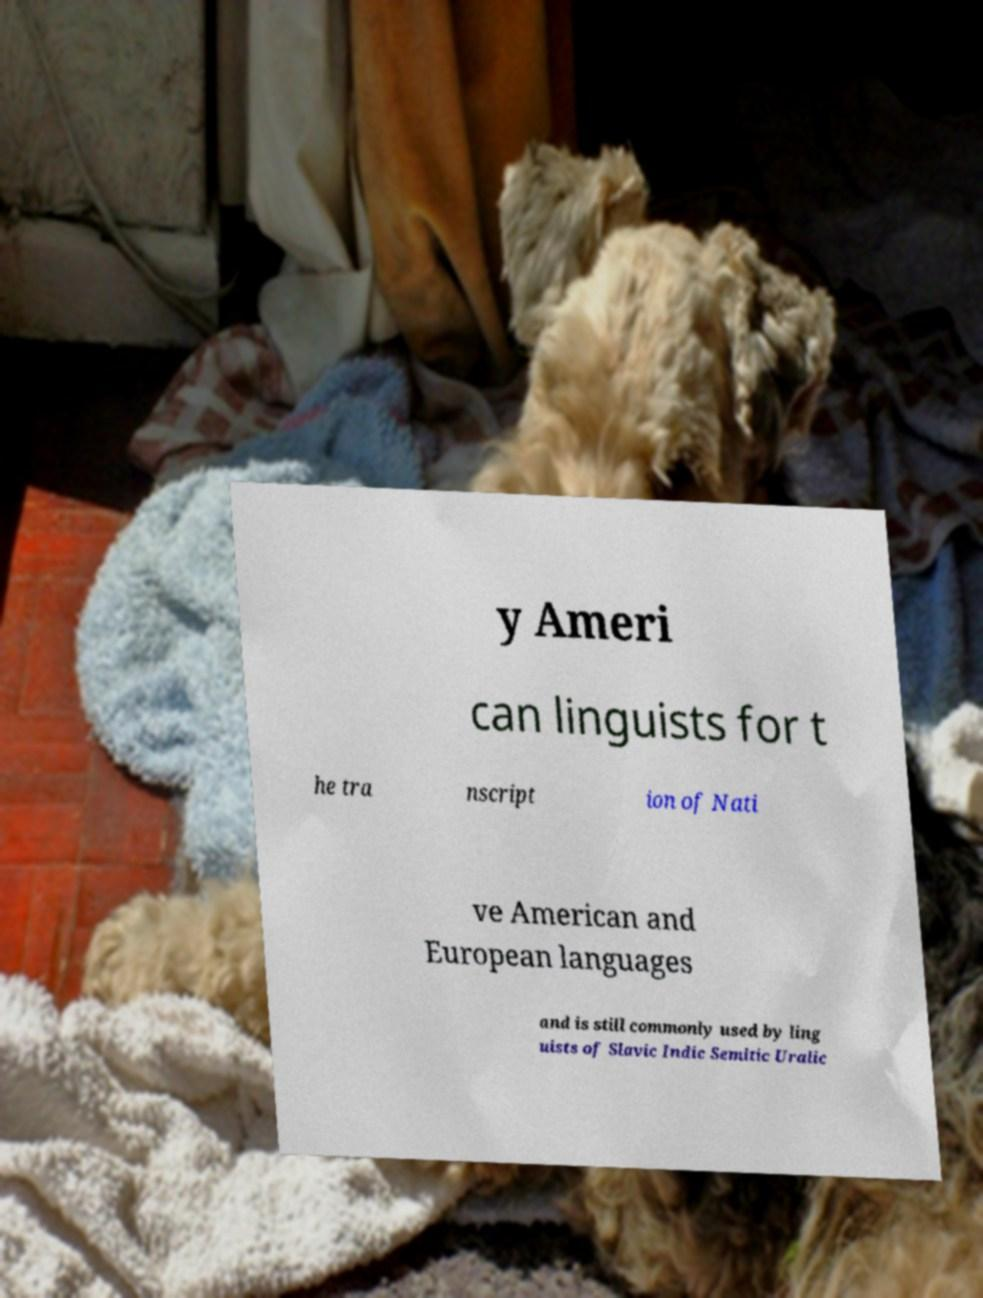Could you extract and type out the text from this image? y Ameri can linguists for t he tra nscript ion of Nati ve American and European languages and is still commonly used by ling uists of Slavic Indic Semitic Uralic 